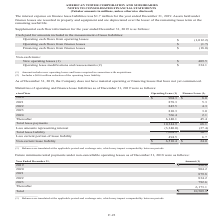According to American Tower Corporation's financial document, What was the operating lease in 2020? According to the financial document, $904.3 (in millions). The relevant text states: "2020 $ 904.3 $ 8.0..." Also, What were operating and finance lease balances translated at? the applicable period-end exchange rate, which may impact comparability between periods.. The document states: "_______________ (1) Balances are translated at the applicable period-end exchange rate, which may impact comparability between periods...." Also, What were the total lease payments for operating lease? According to the financial document, 10,344.9 (in millions). The relevant text states: "Total lease payments 10,344.9 68.1 Less amounts representing interest (3,340.0) (37.4)..." Also, can you calculate: What was the sum of operating lease in fiscal years 2020-2022? Based on the calculation: $904.3+878.3+845.5, the result is 2628.1 (in millions). This is based on the information: "2021 878.3 5.3 2020 $ 904.3 $ 8.0 2022 845.5 4.3 2023 810.3 3.0..." The key data points involved are: 845.5, 878.3, 904.3. Also, can you calculate: What was the change in finance leases between 2020 and 2021? Based on the calculation: 5.3-8.0, the result is -2.7 (in millions). This is based on the information: "Financing cash flows from finance leases $ (18.0) 2021 878.3 5.3..." The key data points involved are: 5.3, 8.0. Also, can you calculate: What is non-current lease liability as a percentage of Total lease liability? Based on the calculation: 6,510.4/7,004.9, the result is 92.94 (percentage). This is based on the information: "Non-current lease liability $ 6,510.4 $ 24.0 Total lease liability 7,004.9 30.7..." The key data points involved are: 6,510.4, 7,004.9. 